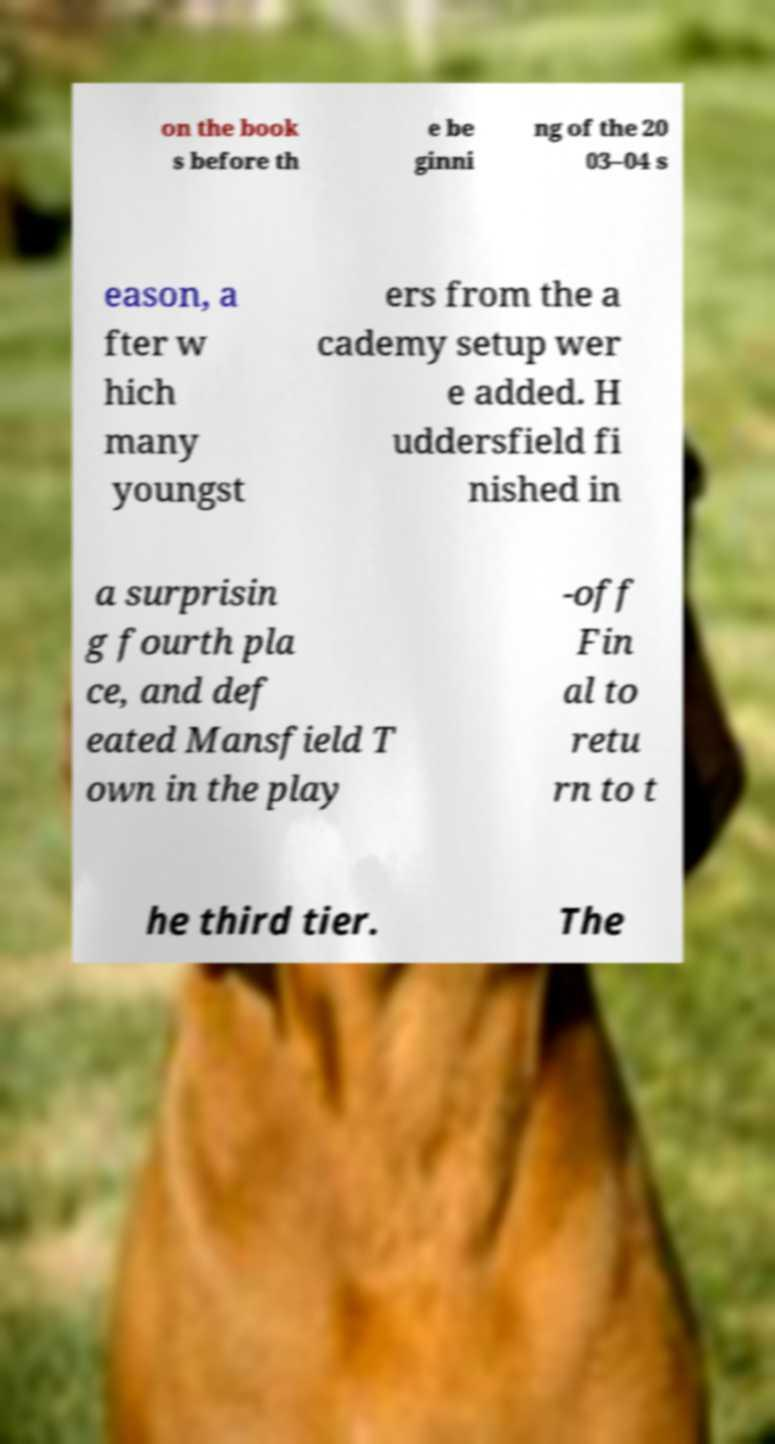There's text embedded in this image that I need extracted. Can you transcribe it verbatim? on the book s before th e be ginni ng of the 20 03–04 s eason, a fter w hich many youngst ers from the a cademy setup wer e added. H uddersfield fi nished in a surprisin g fourth pla ce, and def eated Mansfield T own in the play -off Fin al to retu rn to t he third tier. The 